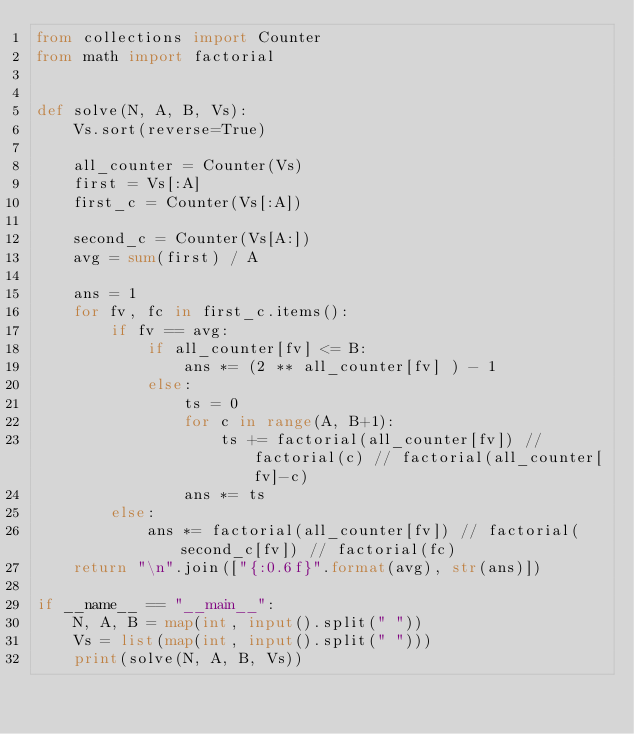<code> <loc_0><loc_0><loc_500><loc_500><_Python_>from collections import Counter
from math import factorial


def solve(N, A, B, Vs):
    Vs.sort(reverse=True)

    all_counter = Counter(Vs)
    first = Vs[:A]
    first_c = Counter(Vs[:A])

    second_c = Counter(Vs[A:])
    avg = sum(first) / A

    ans = 1
    for fv, fc in first_c.items():
        if fv == avg:
            if all_counter[fv] <= B:
                ans *= (2 ** all_counter[fv] ) - 1
            else:
                ts = 0
                for c in range(A, B+1):
                    ts += factorial(all_counter[fv]) // factorial(c) // factorial(all_counter[fv]-c)
                ans *= ts
        else:
            ans *= factorial(all_counter[fv]) // factorial(second_c[fv]) // factorial(fc)
    return "\n".join(["{:0.6f}".format(avg), str(ans)])

if __name__ == "__main__":
    N, A, B = map(int, input().split(" "))
    Vs = list(map(int, input().split(" ")))
    print(solve(N, A, B, Vs))
</code> 